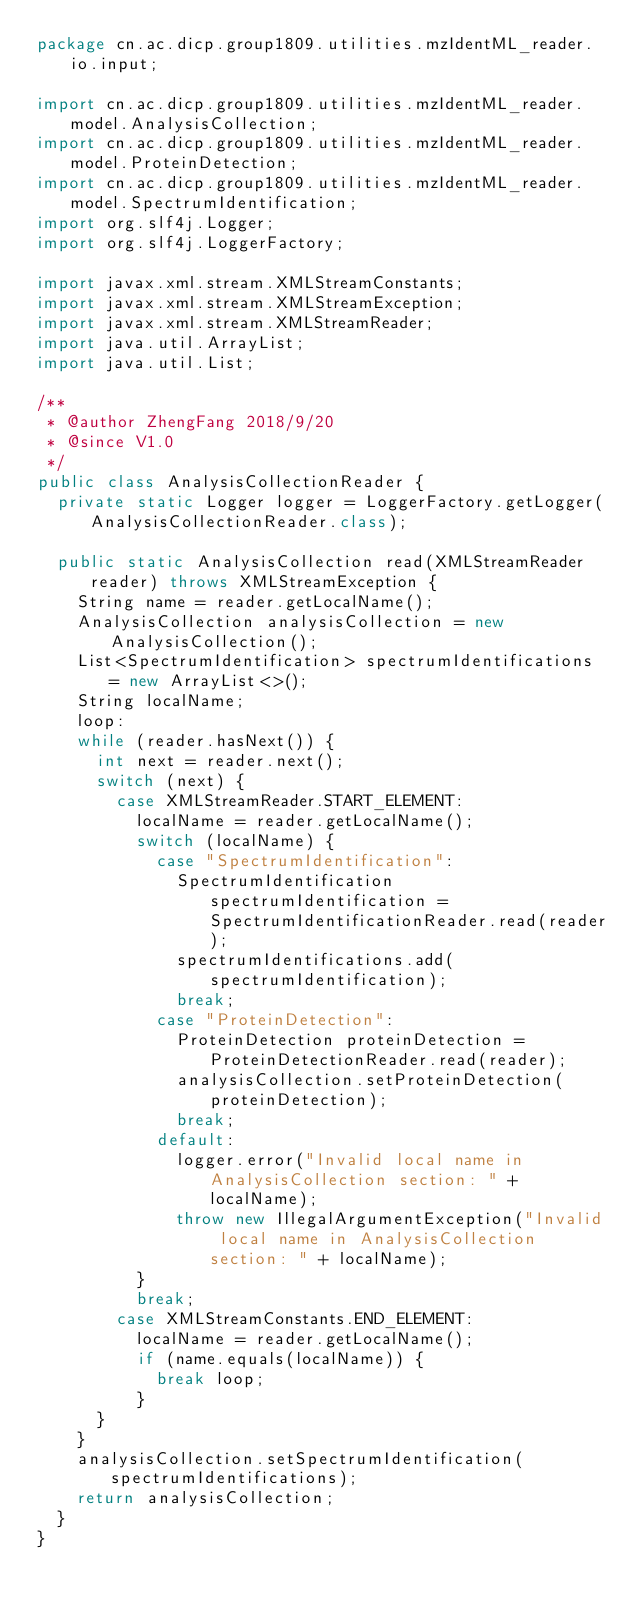Convert code to text. <code><loc_0><loc_0><loc_500><loc_500><_Java_>package cn.ac.dicp.group1809.utilities.mzIdentML_reader.io.input;

import cn.ac.dicp.group1809.utilities.mzIdentML_reader.model.AnalysisCollection;
import cn.ac.dicp.group1809.utilities.mzIdentML_reader.model.ProteinDetection;
import cn.ac.dicp.group1809.utilities.mzIdentML_reader.model.SpectrumIdentification;
import org.slf4j.Logger;
import org.slf4j.LoggerFactory;

import javax.xml.stream.XMLStreamConstants;
import javax.xml.stream.XMLStreamException;
import javax.xml.stream.XMLStreamReader;
import java.util.ArrayList;
import java.util.List;

/**
 * @author ZhengFang 2018/9/20
 * @since V1.0
 */
public class AnalysisCollectionReader {
	private static Logger logger = LoggerFactory.getLogger(AnalysisCollectionReader.class);

	public static AnalysisCollection read(XMLStreamReader reader) throws XMLStreamException {
		String name = reader.getLocalName();
		AnalysisCollection analysisCollection = new AnalysisCollection();
		List<SpectrumIdentification> spectrumIdentifications = new ArrayList<>();
		String localName;
		loop:
		while (reader.hasNext()) {
			int next = reader.next();
			switch (next) {
				case XMLStreamReader.START_ELEMENT:
					localName = reader.getLocalName();
					switch (localName) {
						case "SpectrumIdentification":
							SpectrumIdentification spectrumIdentification = SpectrumIdentificationReader.read(reader);
							spectrumIdentifications.add(spectrumIdentification);
							break;
						case "ProteinDetection":
							ProteinDetection proteinDetection = ProteinDetectionReader.read(reader);
							analysisCollection.setProteinDetection(proteinDetection);
							break;
						default:
							logger.error("Invalid local name in AnalysisCollection section: " + localName);
							throw new IllegalArgumentException("Invalid local name in AnalysisCollection section: " + localName);
					}
					break;
				case XMLStreamConstants.END_ELEMENT:
					localName = reader.getLocalName();
					if (name.equals(localName)) {
						break loop;
					}
			}
		}
		analysisCollection.setSpectrumIdentification(spectrumIdentifications);
		return analysisCollection;
	}
}
</code> 